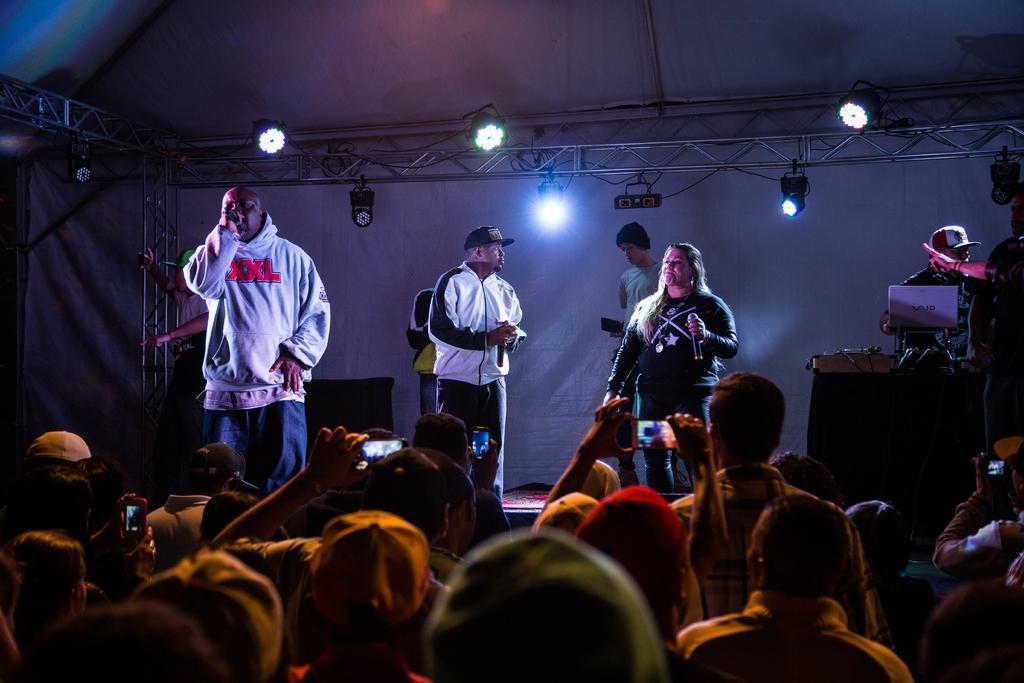In one or two sentences, can you explain what this image depicts? In this image, we can see a group of people. In the middle, we can see three people are standing and holding a microphone in their hands. On the right side, we can see two people and the man is standing in front of the table, on that table, we can see a laptop and a microphone. In the background, we can see a man, curtains, lights and a table. At the top, we can see a tent with few lights, at the bottom, we can see a group of people and few people are holding mobile in their hands. 